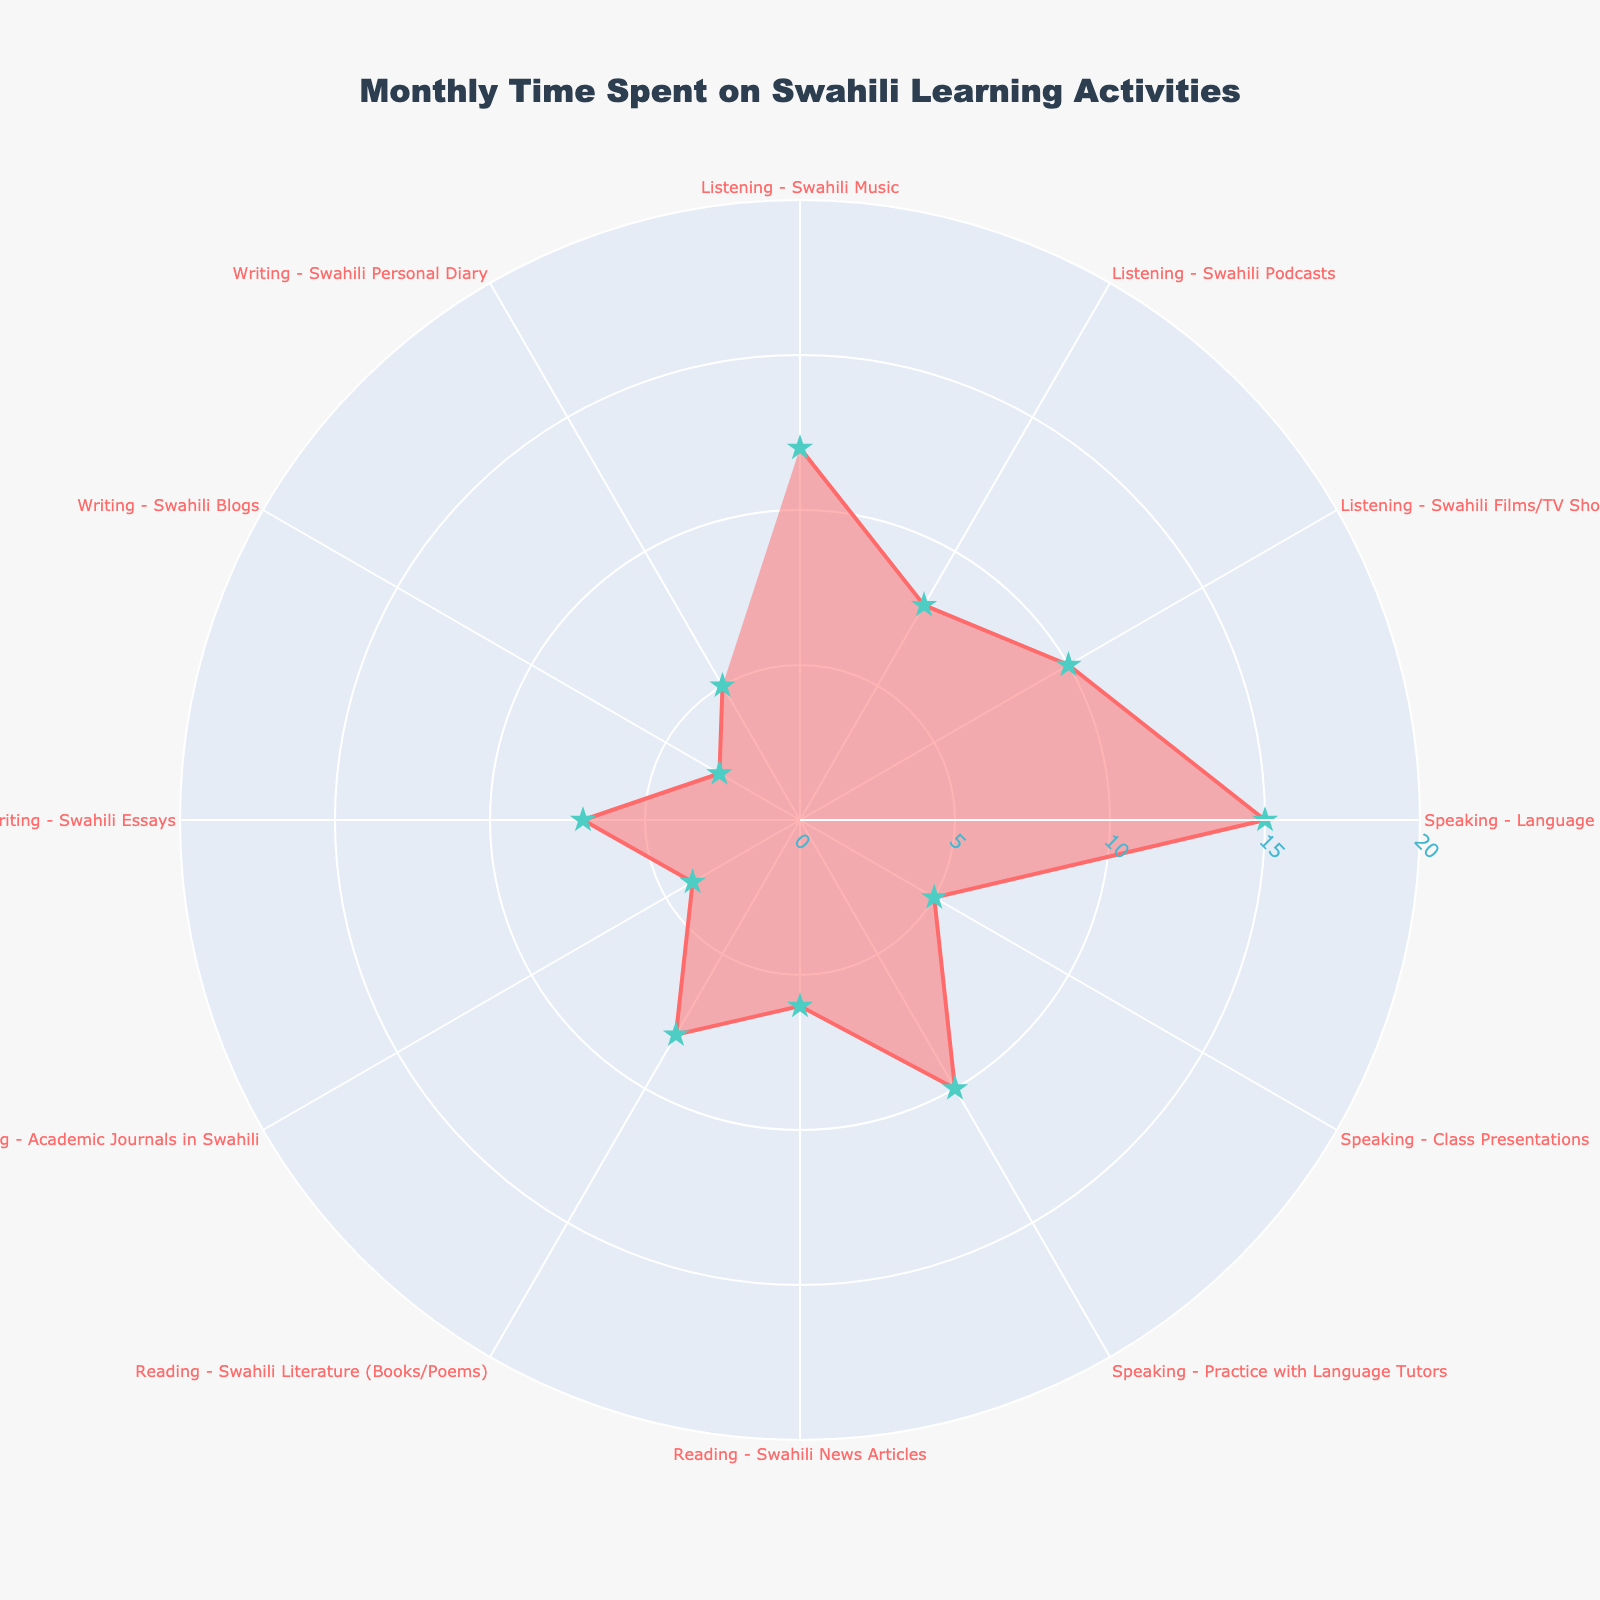What's the title of the chart? The title of the chart is typically located at the top center part of the figure. By observing the given polar chart, we can find the title text clearly displayed.
Answer: Monthly Time Spent on Swahili Learning Activities How many data points are there in the chart? Each distinct language learning activity is represented by a data point on the polar chart. By counting each activity listed around the radius, we get the total number of data points.
Answer: 12 Which language activity did you spend the most time on? The activity with the highest radial distance from the center represents the one with the most time spent. By comparing all points, we identify the one farthest from the center.
Answer: Speaking - Language Exchange with Friends Which language activity did you spend the least time on? The activity with the shortest radial distance from the center represents the one with the least time spent. By comparing all points, we find the one closest to the center.
Answer: Writing - Swahili Blogs What's the total time spent on reading activities? To find the total time spent on reading, we add up the hours from the three data points related to reading activities: Swahili News Articles, Swahili Literature (Books/Poems), and Academic Journals in Swahili.
Answer: 6 + 8 + 4 = 18 What is the difference between the time spent on Listening - Swahili Music and Listening - Swahili Podcasts? To find the difference, subtract the time spent on Swahili Podcasts from the time spent on Swahili Music.
Answer: 12 - 8 = 4 Compare the time spent on Speaking activities to Reading activities. Which category has more total hours? First, sum the hours spent on each individual activity within Speaking and Reading categories. Then compare the sums to determine which is greater.
Answer: Speaking: 15 + 5 + 10 = 30, Reading: 6 + 8 + 4 = 18. Speaking has more total hours Which listening activity has the second highest time spent? Identify the listening activities and then sort them by time spent. Select the second highest value.
Answer: Listening - Swahili Films/TV Shows What is the average time spent on Writing activities? To find the average, sum the hours for each writing activity and divide by the number of writing activities.
Answer: (7 + 3 + 5) / 3 = 15 / 3 = 5 How many activities have a time spent above 10 hours? Count the number of activities where the radial distance (time spent) is greater than 10 hours by observing the figure.
Answer: 3 